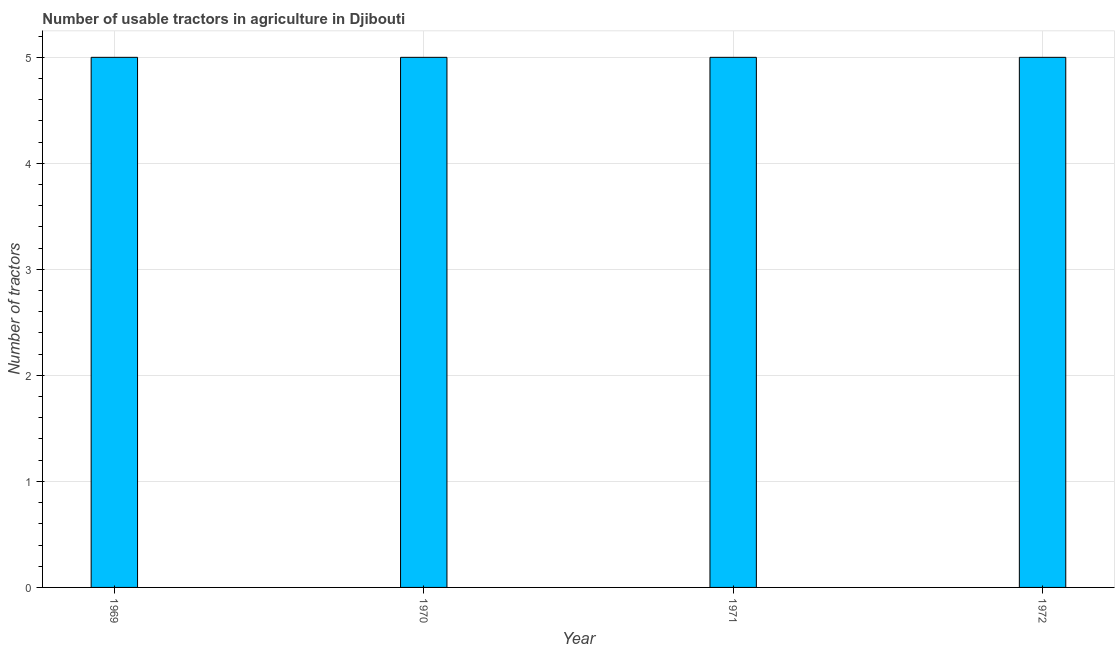Does the graph contain any zero values?
Your response must be concise. No. What is the title of the graph?
Your answer should be compact. Number of usable tractors in agriculture in Djibouti. What is the label or title of the X-axis?
Your answer should be compact. Year. What is the label or title of the Y-axis?
Ensure brevity in your answer.  Number of tractors. Across all years, what is the maximum number of tractors?
Ensure brevity in your answer.  5. Across all years, what is the minimum number of tractors?
Offer a terse response. 5. In which year was the number of tractors maximum?
Offer a very short reply. 1969. In which year was the number of tractors minimum?
Your response must be concise. 1969. What is the average number of tractors per year?
Ensure brevity in your answer.  5. What is the median number of tractors?
Your answer should be very brief. 5. In how many years, is the number of tractors greater than 3.2 ?
Your answer should be very brief. 4. Do a majority of the years between 1972 and 1971 (inclusive) have number of tractors greater than 1 ?
Give a very brief answer. No. Is the number of tractors in 1969 less than that in 1972?
Your response must be concise. No. What is the difference between the highest and the second highest number of tractors?
Make the answer very short. 0. Is the sum of the number of tractors in 1969 and 1971 greater than the maximum number of tractors across all years?
Ensure brevity in your answer.  Yes. What is the difference between the highest and the lowest number of tractors?
Provide a succinct answer. 0. In how many years, is the number of tractors greater than the average number of tractors taken over all years?
Give a very brief answer. 0. What is the difference between two consecutive major ticks on the Y-axis?
Your answer should be very brief. 1. What is the Number of tractors of 1969?
Provide a succinct answer. 5. What is the Number of tractors in 1970?
Keep it short and to the point. 5. What is the Number of tractors in 1972?
Provide a succinct answer. 5. What is the difference between the Number of tractors in 1969 and 1970?
Your answer should be compact. 0. What is the difference between the Number of tractors in 1969 and 1971?
Give a very brief answer. 0. 